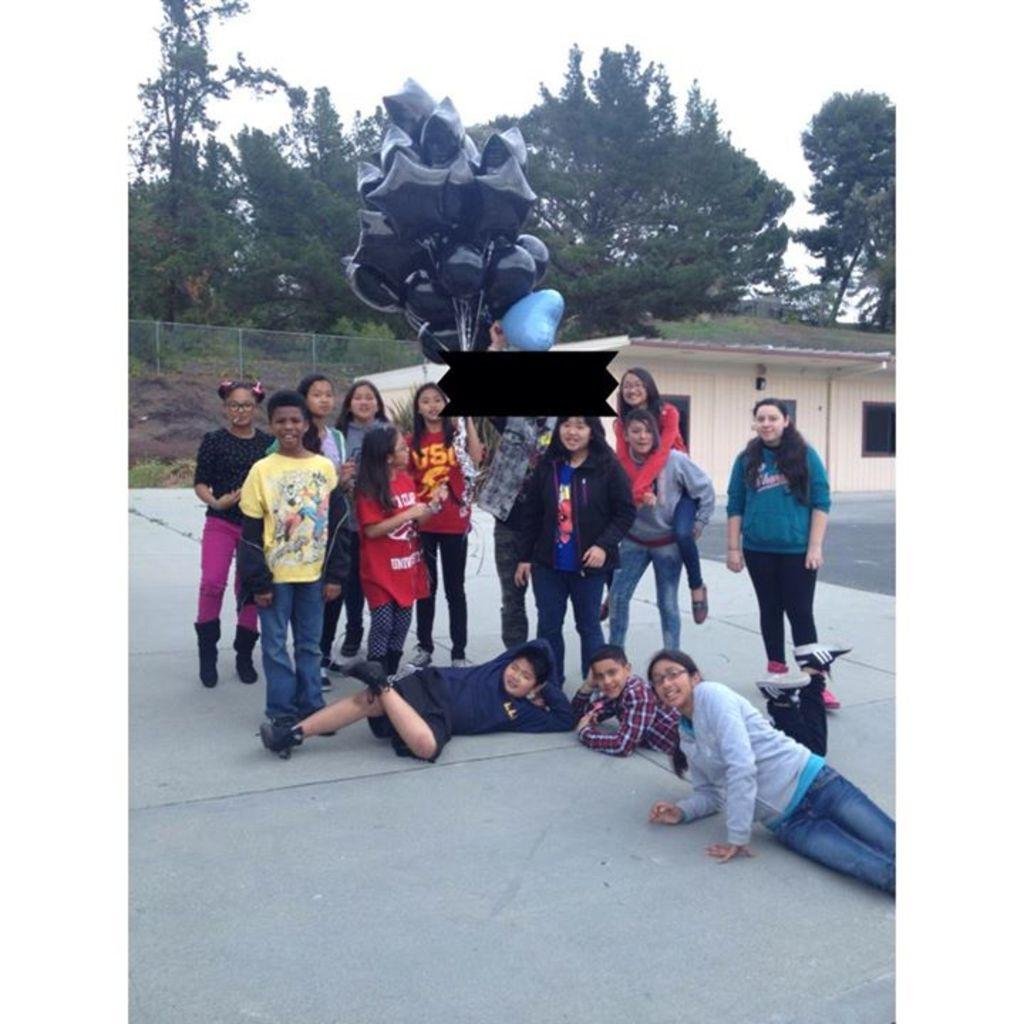What is happening with the group of people in the image? The group of people are posing for a photo. Can you describe any specific details about the people in the group? One person in the group is holding a lot of balloons. What can be seen in the background of the image? There are many trees visible in the background of the image. What type of belief is being expressed by the chickens in the image? There are no chickens present in the image, so it is not possible to determine any beliefs they might express. 